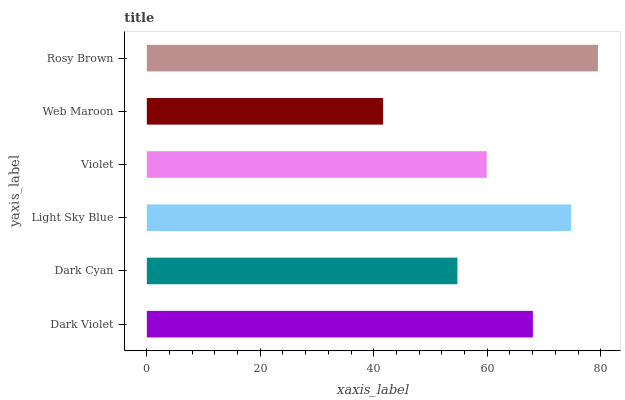Is Web Maroon the minimum?
Answer yes or no. Yes. Is Rosy Brown the maximum?
Answer yes or no. Yes. Is Dark Cyan the minimum?
Answer yes or no. No. Is Dark Cyan the maximum?
Answer yes or no. No. Is Dark Violet greater than Dark Cyan?
Answer yes or no. Yes. Is Dark Cyan less than Dark Violet?
Answer yes or no. Yes. Is Dark Cyan greater than Dark Violet?
Answer yes or no. No. Is Dark Violet less than Dark Cyan?
Answer yes or no. No. Is Dark Violet the high median?
Answer yes or no. Yes. Is Violet the low median?
Answer yes or no. Yes. Is Light Sky Blue the high median?
Answer yes or no. No. Is Web Maroon the low median?
Answer yes or no. No. 